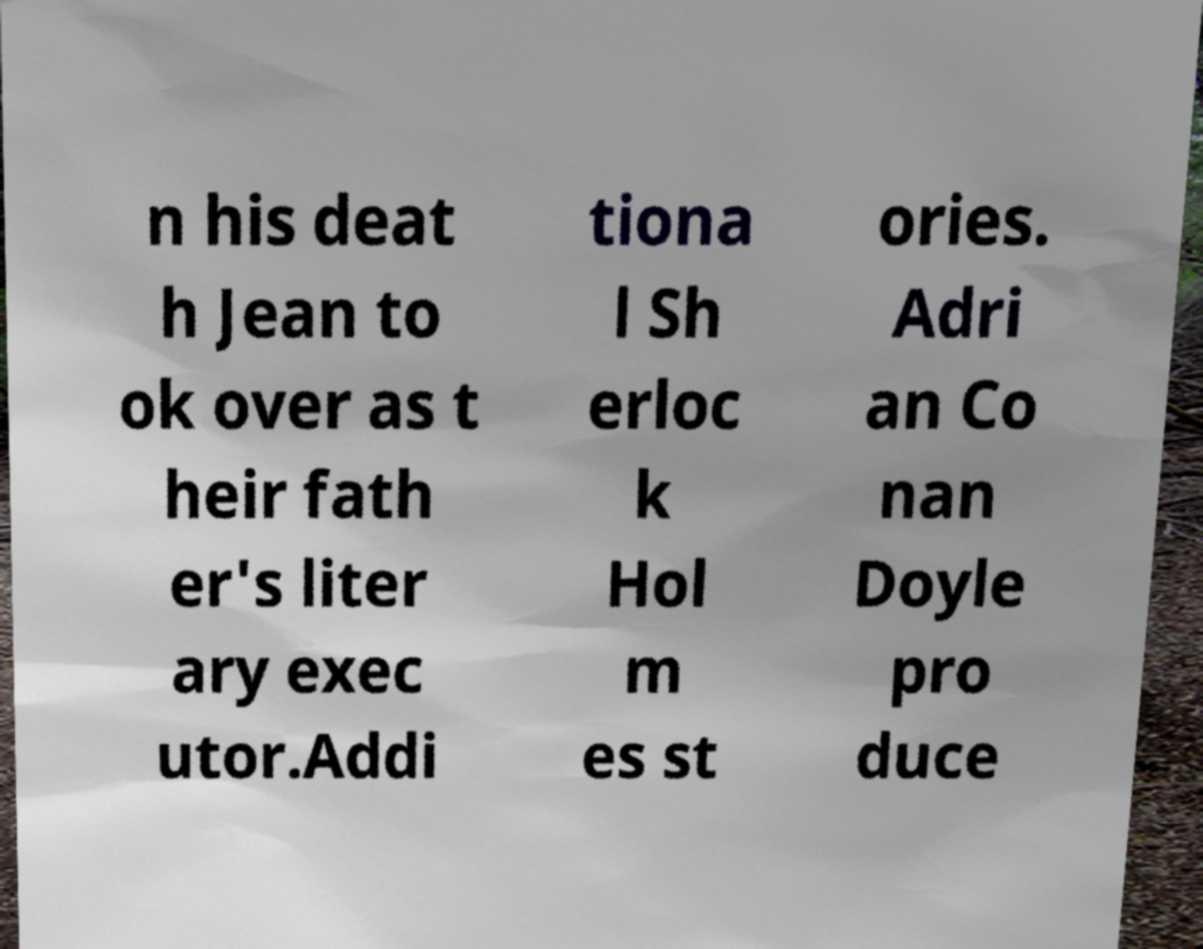Please identify and transcribe the text found in this image. n his deat h Jean to ok over as t heir fath er's liter ary exec utor.Addi tiona l Sh erloc k Hol m es st ories. Adri an Co nan Doyle pro duce 